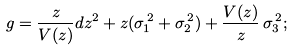Convert formula to latex. <formula><loc_0><loc_0><loc_500><loc_500>g = \frac { z } { V ( z ) } d z ^ { 2 } + z ( \sigma _ { 1 } ^ { \, 2 } + \sigma _ { 2 } ^ { \, 2 } ) + \frac { V ( z ) } { z } \, \sigma _ { 3 } ^ { \, 2 } ;</formula> 